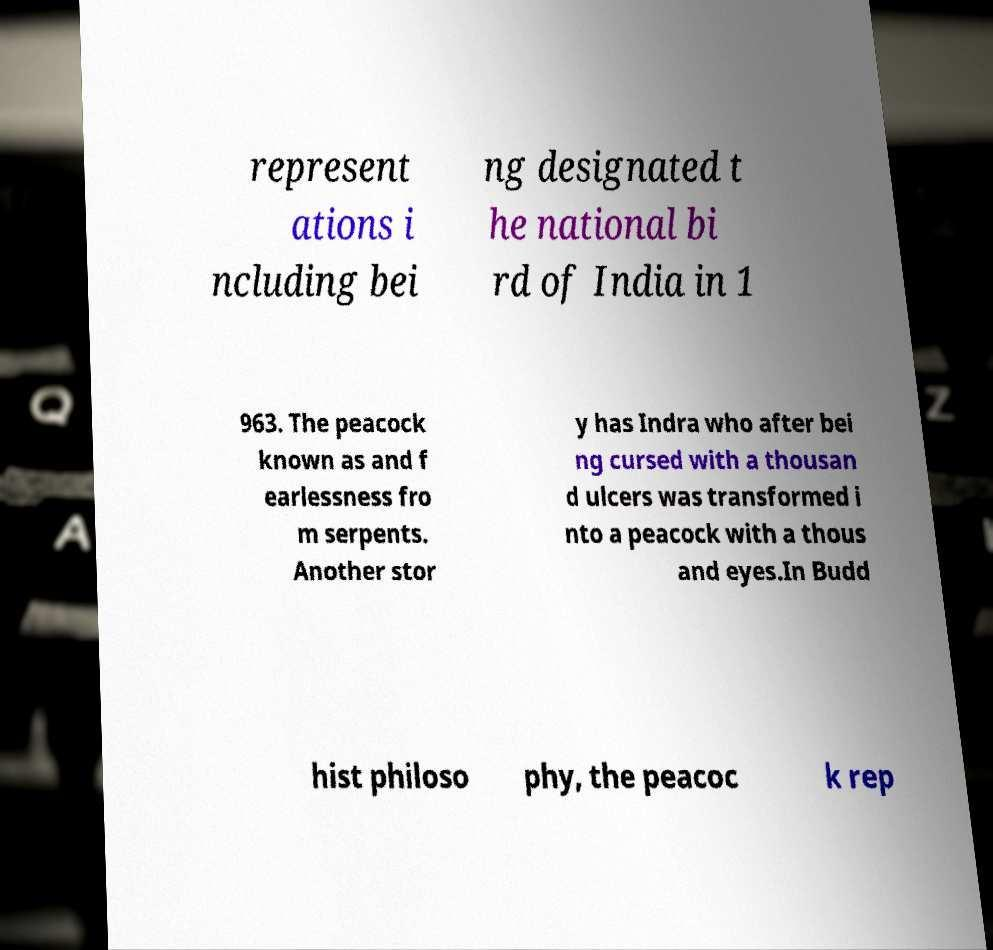For documentation purposes, I need the text within this image transcribed. Could you provide that? represent ations i ncluding bei ng designated t he national bi rd of India in 1 963. The peacock known as and f earlessness fro m serpents. Another stor y has Indra who after bei ng cursed with a thousan d ulcers was transformed i nto a peacock with a thous and eyes.In Budd hist philoso phy, the peacoc k rep 